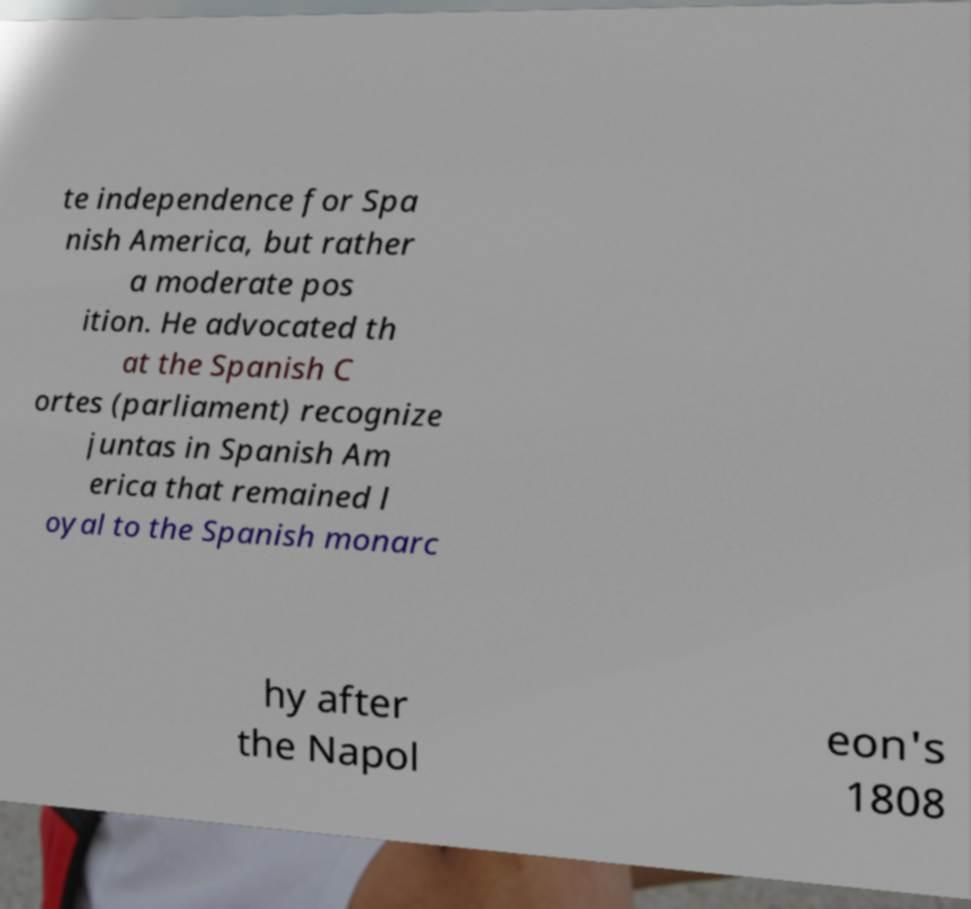What messages or text are displayed in this image? I need them in a readable, typed format. te independence for Spa nish America, but rather a moderate pos ition. He advocated th at the Spanish C ortes (parliament) recognize juntas in Spanish Am erica that remained l oyal to the Spanish monarc hy after the Napol eon's 1808 